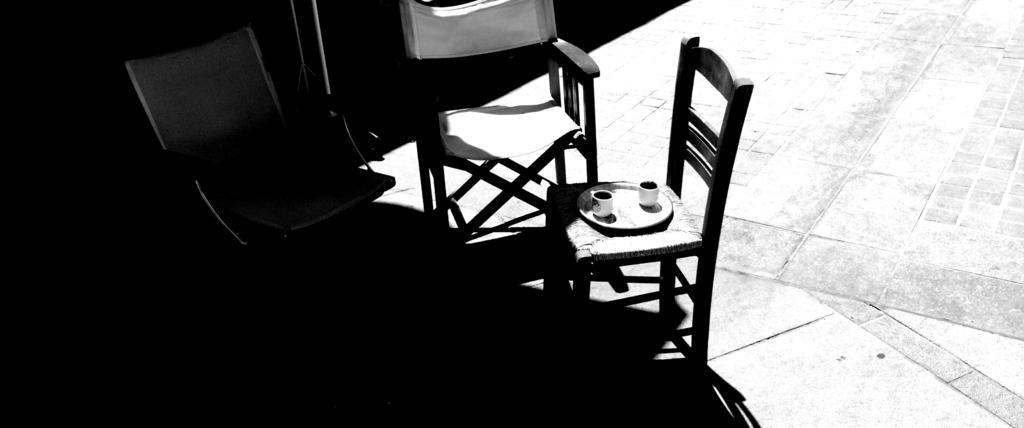In one or two sentences, can you explain what this image depicts? This is a black and white image. In this image we can see three chairs. There is a plate with two cups on it. At the bottom of the image there is floor. 